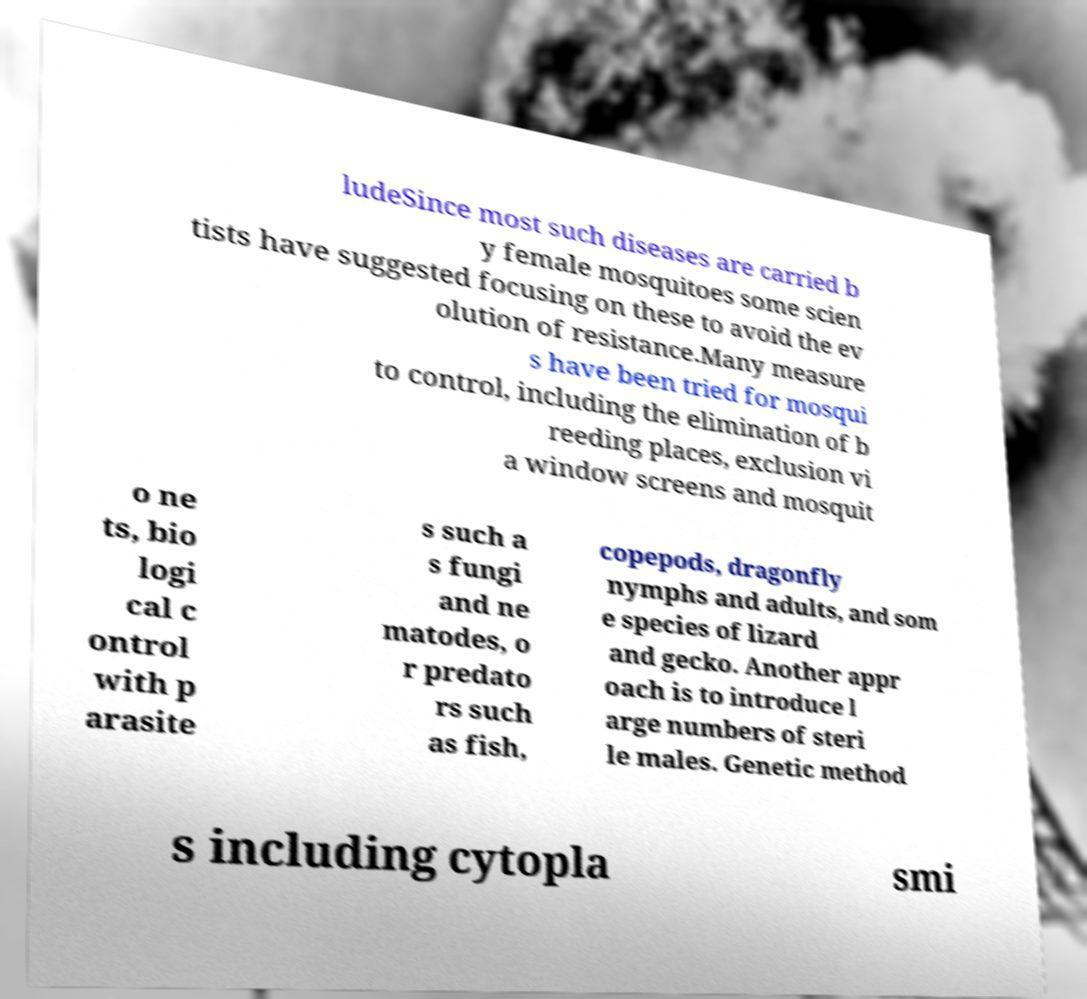I need the written content from this picture converted into text. Can you do that? ludeSince most such diseases are carried b y female mosquitoes some scien tists have suggested focusing on these to avoid the ev olution of resistance.Many measure s have been tried for mosqui to control, including the elimination of b reeding places, exclusion vi a window screens and mosquit o ne ts, bio logi cal c ontrol with p arasite s such a s fungi and ne matodes, o r predato rs such as fish, copepods, dragonfly nymphs and adults, and som e species of lizard and gecko. Another appr oach is to introduce l arge numbers of steri le males. Genetic method s including cytopla smi 